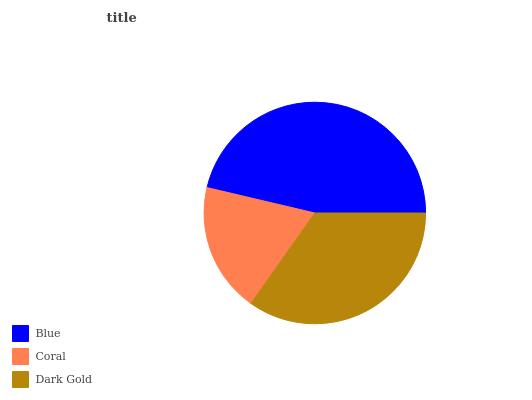Is Coral the minimum?
Answer yes or no. Yes. Is Blue the maximum?
Answer yes or no. Yes. Is Dark Gold the minimum?
Answer yes or no. No. Is Dark Gold the maximum?
Answer yes or no. No. Is Dark Gold greater than Coral?
Answer yes or no. Yes. Is Coral less than Dark Gold?
Answer yes or no. Yes. Is Coral greater than Dark Gold?
Answer yes or no. No. Is Dark Gold less than Coral?
Answer yes or no. No. Is Dark Gold the high median?
Answer yes or no. Yes. Is Dark Gold the low median?
Answer yes or no. Yes. Is Blue the high median?
Answer yes or no. No. Is Blue the low median?
Answer yes or no. No. 